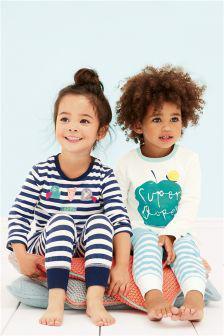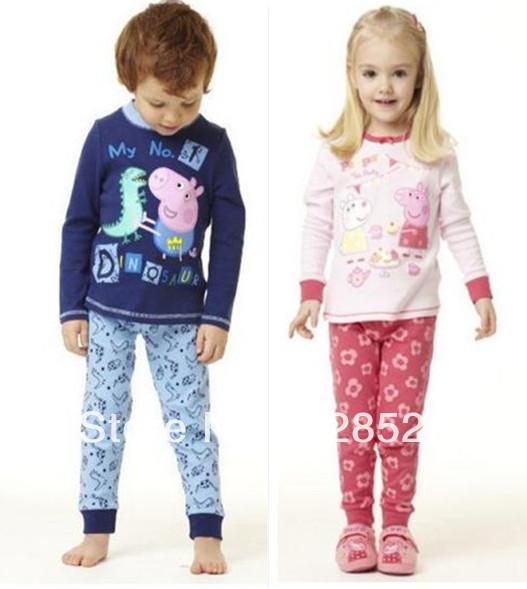The first image is the image on the left, the second image is the image on the right. Examine the images to the left and right. Is the description "Some outfits feature a pink cartoon pig, and each image contains exactly two sleepwear outfits." accurate? Answer yes or no. Yes. The first image is the image on the left, the second image is the image on the right. Assess this claim about the two images: "Clothing is being modeled by children in each of the images.". Correct or not? Answer yes or no. Yes. 